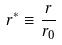Convert formula to latex. <formula><loc_0><loc_0><loc_500><loc_500>r ^ { * } \equiv \frac { r } { r _ { 0 } }</formula> 